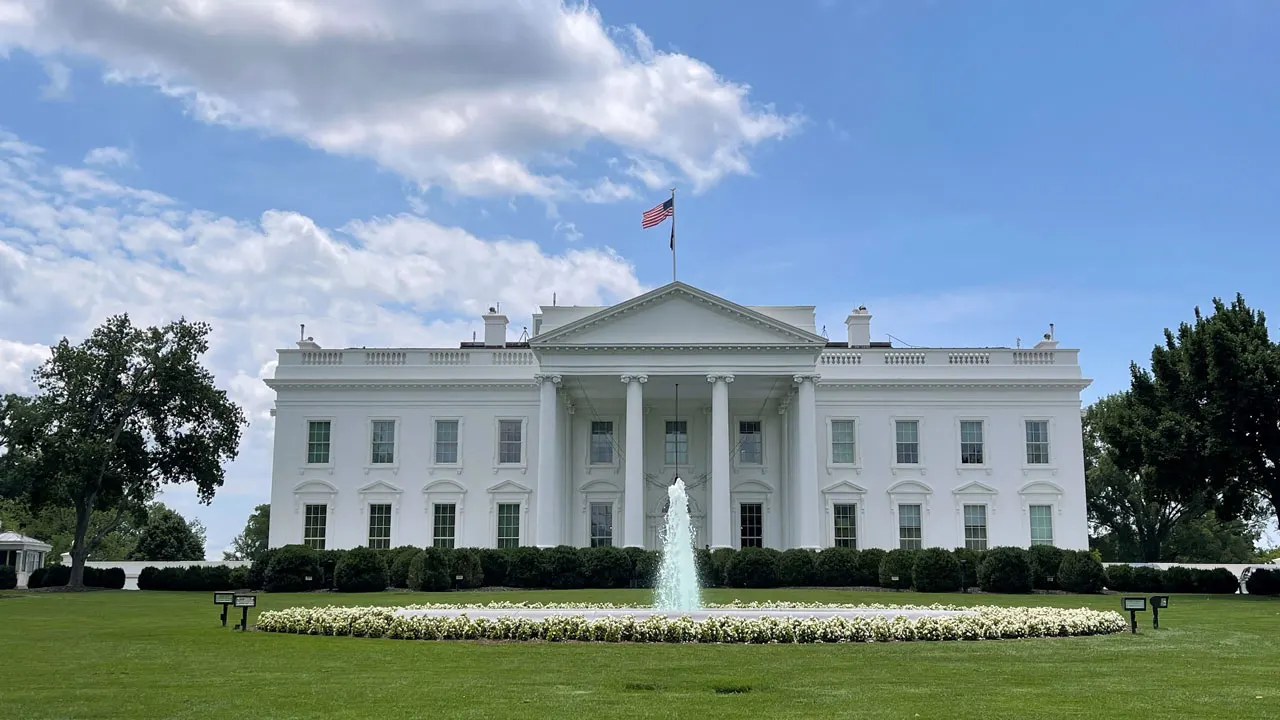How does this image reflect on the role of the president? This image, focusing on the White House, encapsulates the dual role of the president as both head of state and head of government. The grandeur and solemnity of the building mirror the gravity of presidential responsibilities, serving as a symbol of executive authority. The flag above it represents the country and highlights the president's role as a national figurehead, while the open lawns and accessible view suggest transparency and the concept of a president being 'of the people.' 